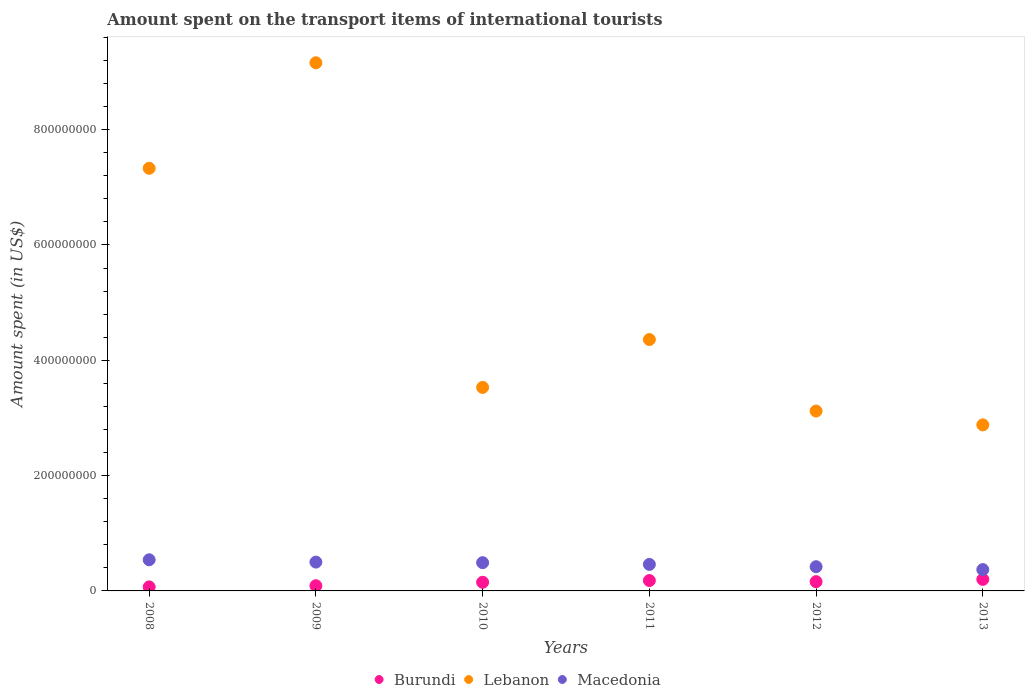How many different coloured dotlines are there?
Ensure brevity in your answer.  3. What is the amount spent on the transport items of international tourists in Macedonia in 2011?
Your response must be concise. 4.60e+07. Across all years, what is the maximum amount spent on the transport items of international tourists in Lebanon?
Offer a very short reply. 9.16e+08. Across all years, what is the minimum amount spent on the transport items of international tourists in Lebanon?
Ensure brevity in your answer.  2.88e+08. What is the total amount spent on the transport items of international tourists in Lebanon in the graph?
Provide a succinct answer. 3.04e+09. What is the difference between the amount spent on the transport items of international tourists in Burundi in 2008 and that in 2011?
Ensure brevity in your answer.  -1.10e+07. What is the difference between the amount spent on the transport items of international tourists in Lebanon in 2008 and the amount spent on the transport items of international tourists in Burundi in 2009?
Provide a short and direct response. 7.24e+08. What is the average amount spent on the transport items of international tourists in Burundi per year?
Your response must be concise. 1.42e+07. In the year 2012, what is the difference between the amount spent on the transport items of international tourists in Lebanon and amount spent on the transport items of international tourists in Macedonia?
Ensure brevity in your answer.  2.70e+08. Is the amount spent on the transport items of international tourists in Macedonia in 2008 less than that in 2012?
Ensure brevity in your answer.  No. Is the difference between the amount spent on the transport items of international tourists in Lebanon in 2008 and 2013 greater than the difference between the amount spent on the transport items of international tourists in Macedonia in 2008 and 2013?
Give a very brief answer. Yes. What is the difference between the highest and the second highest amount spent on the transport items of international tourists in Lebanon?
Ensure brevity in your answer.  1.83e+08. What is the difference between the highest and the lowest amount spent on the transport items of international tourists in Macedonia?
Provide a succinct answer. 1.70e+07. Is the sum of the amount spent on the transport items of international tourists in Macedonia in 2008 and 2009 greater than the maximum amount spent on the transport items of international tourists in Burundi across all years?
Your response must be concise. Yes. Is it the case that in every year, the sum of the amount spent on the transport items of international tourists in Burundi and amount spent on the transport items of international tourists in Macedonia  is greater than the amount spent on the transport items of international tourists in Lebanon?
Your answer should be compact. No. Is the amount spent on the transport items of international tourists in Burundi strictly greater than the amount spent on the transport items of international tourists in Macedonia over the years?
Ensure brevity in your answer.  No. Is the amount spent on the transport items of international tourists in Macedonia strictly less than the amount spent on the transport items of international tourists in Lebanon over the years?
Make the answer very short. Yes. Are the values on the major ticks of Y-axis written in scientific E-notation?
Keep it short and to the point. No. Does the graph contain grids?
Provide a succinct answer. No. Where does the legend appear in the graph?
Keep it short and to the point. Bottom center. How many legend labels are there?
Keep it short and to the point. 3. How are the legend labels stacked?
Make the answer very short. Horizontal. What is the title of the graph?
Make the answer very short. Amount spent on the transport items of international tourists. What is the label or title of the Y-axis?
Make the answer very short. Amount spent (in US$). What is the Amount spent (in US$) in Lebanon in 2008?
Your answer should be very brief. 7.33e+08. What is the Amount spent (in US$) of Macedonia in 2008?
Your response must be concise. 5.40e+07. What is the Amount spent (in US$) of Burundi in 2009?
Offer a very short reply. 9.00e+06. What is the Amount spent (in US$) in Lebanon in 2009?
Make the answer very short. 9.16e+08. What is the Amount spent (in US$) of Burundi in 2010?
Your response must be concise. 1.50e+07. What is the Amount spent (in US$) of Lebanon in 2010?
Keep it short and to the point. 3.53e+08. What is the Amount spent (in US$) of Macedonia in 2010?
Offer a terse response. 4.90e+07. What is the Amount spent (in US$) of Burundi in 2011?
Your answer should be compact. 1.80e+07. What is the Amount spent (in US$) of Lebanon in 2011?
Provide a short and direct response. 4.36e+08. What is the Amount spent (in US$) of Macedonia in 2011?
Your response must be concise. 4.60e+07. What is the Amount spent (in US$) of Burundi in 2012?
Make the answer very short. 1.60e+07. What is the Amount spent (in US$) of Lebanon in 2012?
Provide a short and direct response. 3.12e+08. What is the Amount spent (in US$) of Macedonia in 2012?
Your answer should be very brief. 4.20e+07. What is the Amount spent (in US$) in Lebanon in 2013?
Keep it short and to the point. 2.88e+08. What is the Amount spent (in US$) in Macedonia in 2013?
Ensure brevity in your answer.  3.70e+07. Across all years, what is the maximum Amount spent (in US$) in Lebanon?
Make the answer very short. 9.16e+08. Across all years, what is the maximum Amount spent (in US$) in Macedonia?
Your answer should be very brief. 5.40e+07. Across all years, what is the minimum Amount spent (in US$) of Lebanon?
Offer a terse response. 2.88e+08. Across all years, what is the minimum Amount spent (in US$) of Macedonia?
Your response must be concise. 3.70e+07. What is the total Amount spent (in US$) in Burundi in the graph?
Your response must be concise. 8.50e+07. What is the total Amount spent (in US$) in Lebanon in the graph?
Offer a terse response. 3.04e+09. What is the total Amount spent (in US$) of Macedonia in the graph?
Make the answer very short. 2.78e+08. What is the difference between the Amount spent (in US$) in Burundi in 2008 and that in 2009?
Make the answer very short. -2.00e+06. What is the difference between the Amount spent (in US$) in Lebanon in 2008 and that in 2009?
Provide a short and direct response. -1.83e+08. What is the difference between the Amount spent (in US$) in Macedonia in 2008 and that in 2009?
Offer a very short reply. 4.00e+06. What is the difference between the Amount spent (in US$) of Burundi in 2008 and that in 2010?
Your response must be concise. -8.00e+06. What is the difference between the Amount spent (in US$) of Lebanon in 2008 and that in 2010?
Your answer should be compact. 3.80e+08. What is the difference between the Amount spent (in US$) of Burundi in 2008 and that in 2011?
Your response must be concise. -1.10e+07. What is the difference between the Amount spent (in US$) of Lebanon in 2008 and that in 2011?
Ensure brevity in your answer.  2.97e+08. What is the difference between the Amount spent (in US$) in Macedonia in 2008 and that in 2011?
Offer a very short reply. 8.00e+06. What is the difference between the Amount spent (in US$) in Burundi in 2008 and that in 2012?
Provide a succinct answer. -9.00e+06. What is the difference between the Amount spent (in US$) of Lebanon in 2008 and that in 2012?
Make the answer very short. 4.21e+08. What is the difference between the Amount spent (in US$) in Burundi in 2008 and that in 2013?
Provide a short and direct response. -1.30e+07. What is the difference between the Amount spent (in US$) of Lebanon in 2008 and that in 2013?
Your answer should be compact. 4.45e+08. What is the difference between the Amount spent (in US$) in Macedonia in 2008 and that in 2013?
Provide a short and direct response. 1.70e+07. What is the difference between the Amount spent (in US$) of Burundi in 2009 and that in 2010?
Keep it short and to the point. -6.00e+06. What is the difference between the Amount spent (in US$) of Lebanon in 2009 and that in 2010?
Keep it short and to the point. 5.63e+08. What is the difference between the Amount spent (in US$) of Burundi in 2009 and that in 2011?
Make the answer very short. -9.00e+06. What is the difference between the Amount spent (in US$) in Lebanon in 2009 and that in 2011?
Provide a short and direct response. 4.80e+08. What is the difference between the Amount spent (in US$) of Macedonia in 2009 and that in 2011?
Offer a very short reply. 4.00e+06. What is the difference between the Amount spent (in US$) of Burundi in 2009 and that in 2012?
Ensure brevity in your answer.  -7.00e+06. What is the difference between the Amount spent (in US$) in Lebanon in 2009 and that in 2012?
Offer a very short reply. 6.04e+08. What is the difference between the Amount spent (in US$) in Macedonia in 2009 and that in 2012?
Your response must be concise. 8.00e+06. What is the difference between the Amount spent (in US$) in Burundi in 2009 and that in 2013?
Offer a terse response. -1.10e+07. What is the difference between the Amount spent (in US$) in Lebanon in 2009 and that in 2013?
Offer a very short reply. 6.28e+08. What is the difference between the Amount spent (in US$) of Macedonia in 2009 and that in 2013?
Your response must be concise. 1.30e+07. What is the difference between the Amount spent (in US$) of Burundi in 2010 and that in 2011?
Ensure brevity in your answer.  -3.00e+06. What is the difference between the Amount spent (in US$) of Lebanon in 2010 and that in 2011?
Offer a very short reply. -8.30e+07. What is the difference between the Amount spent (in US$) of Macedonia in 2010 and that in 2011?
Ensure brevity in your answer.  3.00e+06. What is the difference between the Amount spent (in US$) of Burundi in 2010 and that in 2012?
Keep it short and to the point. -1.00e+06. What is the difference between the Amount spent (in US$) in Lebanon in 2010 and that in 2012?
Offer a very short reply. 4.10e+07. What is the difference between the Amount spent (in US$) of Macedonia in 2010 and that in 2012?
Provide a short and direct response. 7.00e+06. What is the difference between the Amount spent (in US$) in Burundi in 2010 and that in 2013?
Provide a short and direct response. -5.00e+06. What is the difference between the Amount spent (in US$) in Lebanon in 2010 and that in 2013?
Offer a terse response. 6.50e+07. What is the difference between the Amount spent (in US$) of Burundi in 2011 and that in 2012?
Offer a terse response. 2.00e+06. What is the difference between the Amount spent (in US$) of Lebanon in 2011 and that in 2012?
Your answer should be compact. 1.24e+08. What is the difference between the Amount spent (in US$) in Lebanon in 2011 and that in 2013?
Give a very brief answer. 1.48e+08. What is the difference between the Amount spent (in US$) of Macedonia in 2011 and that in 2013?
Ensure brevity in your answer.  9.00e+06. What is the difference between the Amount spent (in US$) of Lebanon in 2012 and that in 2013?
Your response must be concise. 2.40e+07. What is the difference between the Amount spent (in US$) of Burundi in 2008 and the Amount spent (in US$) of Lebanon in 2009?
Provide a succinct answer. -9.09e+08. What is the difference between the Amount spent (in US$) of Burundi in 2008 and the Amount spent (in US$) of Macedonia in 2009?
Offer a very short reply. -4.30e+07. What is the difference between the Amount spent (in US$) in Lebanon in 2008 and the Amount spent (in US$) in Macedonia in 2009?
Keep it short and to the point. 6.83e+08. What is the difference between the Amount spent (in US$) of Burundi in 2008 and the Amount spent (in US$) of Lebanon in 2010?
Keep it short and to the point. -3.46e+08. What is the difference between the Amount spent (in US$) of Burundi in 2008 and the Amount spent (in US$) of Macedonia in 2010?
Your response must be concise. -4.20e+07. What is the difference between the Amount spent (in US$) in Lebanon in 2008 and the Amount spent (in US$) in Macedonia in 2010?
Give a very brief answer. 6.84e+08. What is the difference between the Amount spent (in US$) of Burundi in 2008 and the Amount spent (in US$) of Lebanon in 2011?
Provide a short and direct response. -4.29e+08. What is the difference between the Amount spent (in US$) in Burundi in 2008 and the Amount spent (in US$) in Macedonia in 2011?
Keep it short and to the point. -3.90e+07. What is the difference between the Amount spent (in US$) in Lebanon in 2008 and the Amount spent (in US$) in Macedonia in 2011?
Make the answer very short. 6.87e+08. What is the difference between the Amount spent (in US$) in Burundi in 2008 and the Amount spent (in US$) in Lebanon in 2012?
Keep it short and to the point. -3.05e+08. What is the difference between the Amount spent (in US$) of Burundi in 2008 and the Amount spent (in US$) of Macedonia in 2012?
Make the answer very short. -3.50e+07. What is the difference between the Amount spent (in US$) in Lebanon in 2008 and the Amount spent (in US$) in Macedonia in 2012?
Your answer should be very brief. 6.91e+08. What is the difference between the Amount spent (in US$) of Burundi in 2008 and the Amount spent (in US$) of Lebanon in 2013?
Keep it short and to the point. -2.81e+08. What is the difference between the Amount spent (in US$) of Burundi in 2008 and the Amount spent (in US$) of Macedonia in 2013?
Your answer should be very brief. -3.00e+07. What is the difference between the Amount spent (in US$) in Lebanon in 2008 and the Amount spent (in US$) in Macedonia in 2013?
Your answer should be very brief. 6.96e+08. What is the difference between the Amount spent (in US$) in Burundi in 2009 and the Amount spent (in US$) in Lebanon in 2010?
Give a very brief answer. -3.44e+08. What is the difference between the Amount spent (in US$) of Burundi in 2009 and the Amount spent (in US$) of Macedonia in 2010?
Give a very brief answer. -4.00e+07. What is the difference between the Amount spent (in US$) of Lebanon in 2009 and the Amount spent (in US$) of Macedonia in 2010?
Your response must be concise. 8.67e+08. What is the difference between the Amount spent (in US$) of Burundi in 2009 and the Amount spent (in US$) of Lebanon in 2011?
Keep it short and to the point. -4.27e+08. What is the difference between the Amount spent (in US$) of Burundi in 2009 and the Amount spent (in US$) of Macedonia in 2011?
Ensure brevity in your answer.  -3.70e+07. What is the difference between the Amount spent (in US$) of Lebanon in 2009 and the Amount spent (in US$) of Macedonia in 2011?
Provide a succinct answer. 8.70e+08. What is the difference between the Amount spent (in US$) in Burundi in 2009 and the Amount spent (in US$) in Lebanon in 2012?
Provide a short and direct response. -3.03e+08. What is the difference between the Amount spent (in US$) of Burundi in 2009 and the Amount spent (in US$) of Macedonia in 2012?
Your answer should be very brief. -3.30e+07. What is the difference between the Amount spent (in US$) of Lebanon in 2009 and the Amount spent (in US$) of Macedonia in 2012?
Provide a short and direct response. 8.74e+08. What is the difference between the Amount spent (in US$) in Burundi in 2009 and the Amount spent (in US$) in Lebanon in 2013?
Make the answer very short. -2.79e+08. What is the difference between the Amount spent (in US$) of Burundi in 2009 and the Amount spent (in US$) of Macedonia in 2013?
Your response must be concise. -2.80e+07. What is the difference between the Amount spent (in US$) of Lebanon in 2009 and the Amount spent (in US$) of Macedonia in 2013?
Give a very brief answer. 8.79e+08. What is the difference between the Amount spent (in US$) in Burundi in 2010 and the Amount spent (in US$) in Lebanon in 2011?
Your answer should be very brief. -4.21e+08. What is the difference between the Amount spent (in US$) in Burundi in 2010 and the Amount spent (in US$) in Macedonia in 2011?
Make the answer very short. -3.10e+07. What is the difference between the Amount spent (in US$) of Lebanon in 2010 and the Amount spent (in US$) of Macedonia in 2011?
Provide a succinct answer. 3.07e+08. What is the difference between the Amount spent (in US$) of Burundi in 2010 and the Amount spent (in US$) of Lebanon in 2012?
Your answer should be very brief. -2.97e+08. What is the difference between the Amount spent (in US$) in Burundi in 2010 and the Amount spent (in US$) in Macedonia in 2012?
Keep it short and to the point. -2.70e+07. What is the difference between the Amount spent (in US$) of Lebanon in 2010 and the Amount spent (in US$) of Macedonia in 2012?
Offer a terse response. 3.11e+08. What is the difference between the Amount spent (in US$) of Burundi in 2010 and the Amount spent (in US$) of Lebanon in 2013?
Make the answer very short. -2.73e+08. What is the difference between the Amount spent (in US$) of Burundi in 2010 and the Amount spent (in US$) of Macedonia in 2013?
Offer a very short reply. -2.20e+07. What is the difference between the Amount spent (in US$) of Lebanon in 2010 and the Amount spent (in US$) of Macedonia in 2013?
Give a very brief answer. 3.16e+08. What is the difference between the Amount spent (in US$) in Burundi in 2011 and the Amount spent (in US$) in Lebanon in 2012?
Give a very brief answer. -2.94e+08. What is the difference between the Amount spent (in US$) in Burundi in 2011 and the Amount spent (in US$) in Macedonia in 2012?
Keep it short and to the point. -2.40e+07. What is the difference between the Amount spent (in US$) in Lebanon in 2011 and the Amount spent (in US$) in Macedonia in 2012?
Offer a terse response. 3.94e+08. What is the difference between the Amount spent (in US$) of Burundi in 2011 and the Amount spent (in US$) of Lebanon in 2013?
Provide a short and direct response. -2.70e+08. What is the difference between the Amount spent (in US$) in Burundi in 2011 and the Amount spent (in US$) in Macedonia in 2013?
Ensure brevity in your answer.  -1.90e+07. What is the difference between the Amount spent (in US$) of Lebanon in 2011 and the Amount spent (in US$) of Macedonia in 2013?
Your answer should be compact. 3.99e+08. What is the difference between the Amount spent (in US$) in Burundi in 2012 and the Amount spent (in US$) in Lebanon in 2013?
Offer a very short reply. -2.72e+08. What is the difference between the Amount spent (in US$) in Burundi in 2012 and the Amount spent (in US$) in Macedonia in 2013?
Provide a succinct answer. -2.10e+07. What is the difference between the Amount spent (in US$) of Lebanon in 2012 and the Amount spent (in US$) of Macedonia in 2013?
Give a very brief answer. 2.75e+08. What is the average Amount spent (in US$) of Burundi per year?
Offer a very short reply. 1.42e+07. What is the average Amount spent (in US$) of Lebanon per year?
Give a very brief answer. 5.06e+08. What is the average Amount spent (in US$) in Macedonia per year?
Provide a short and direct response. 4.63e+07. In the year 2008, what is the difference between the Amount spent (in US$) in Burundi and Amount spent (in US$) in Lebanon?
Offer a terse response. -7.26e+08. In the year 2008, what is the difference between the Amount spent (in US$) of Burundi and Amount spent (in US$) of Macedonia?
Keep it short and to the point. -4.70e+07. In the year 2008, what is the difference between the Amount spent (in US$) of Lebanon and Amount spent (in US$) of Macedonia?
Your answer should be very brief. 6.79e+08. In the year 2009, what is the difference between the Amount spent (in US$) in Burundi and Amount spent (in US$) in Lebanon?
Provide a succinct answer. -9.07e+08. In the year 2009, what is the difference between the Amount spent (in US$) of Burundi and Amount spent (in US$) of Macedonia?
Provide a succinct answer. -4.10e+07. In the year 2009, what is the difference between the Amount spent (in US$) in Lebanon and Amount spent (in US$) in Macedonia?
Offer a terse response. 8.66e+08. In the year 2010, what is the difference between the Amount spent (in US$) in Burundi and Amount spent (in US$) in Lebanon?
Offer a terse response. -3.38e+08. In the year 2010, what is the difference between the Amount spent (in US$) in Burundi and Amount spent (in US$) in Macedonia?
Ensure brevity in your answer.  -3.40e+07. In the year 2010, what is the difference between the Amount spent (in US$) of Lebanon and Amount spent (in US$) of Macedonia?
Your answer should be compact. 3.04e+08. In the year 2011, what is the difference between the Amount spent (in US$) of Burundi and Amount spent (in US$) of Lebanon?
Provide a succinct answer. -4.18e+08. In the year 2011, what is the difference between the Amount spent (in US$) in Burundi and Amount spent (in US$) in Macedonia?
Offer a terse response. -2.80e+07. In the year 2011, what is the difference between the Amount spent (in US$) in Lebanon and Amount spent (in US$) in Macedonia?
Make the answer very short. 3.90e+08. In the year 2012, what is the difference between the Amount spent (in US$) in Burundi and Amount spent (in US$) in Lebanon?
Offer a very short reply. -2.96e+08. In the year 2012, what is the difference between the Amount spent (in US$) in Burundi and Amount spent (in US$) in Macedonia?
Your response must be concise. -2.60e+07. In the year 2012, what is the difference between the Amount spent (in US$) of Lebanon and Amount spent (in US$) of Macedonia?
Make the answer very short. 2.70e+08. In the year 2013, what is the difference between the Amount spent (in US$) in Burundi and Amount spent (in US$) in Lebanon?
Provide a succinct answer. -2.68e+08. In the year 2013, what is the difference between the Amount spent (in US$) of Burundi and Amount spent (in US$) of Macedonia?
Keep it short and to the point. -1.70e+07. In the year 2013, what is the difference between the Amount spent (in US$) of Lebanon and Amount spent (in US$) of Macedonia?
Your answer should be compact. 2.51e+08. What is the ratio of the Amount spent (in US$) of Lebanon in 2008 to that in 2009?
Your answer should be very brief. 0.8. What is the ratio of the Amount spent (in US$) in Macedonia in 2008 to that in 2009?
Your answer should be compact. 1.08. What is the ratio of the Amount spent (in US$) of Burundi in 2008 to that in 2010?
Your answer should be very brief. 0.47. What is the ratio of the Amount spent (in US$) in Lebanon in 2008 to that in 2010?
Ensure brevity in your answer.  2.08. What is the ratio of the Amount spent (in US$) in Macedonia in 2008 to that in 2010?
Your response must be concise. 1.1. What is the ratio of the Amount spent (in US$) in Burundi in 2008 to that in 2011?
Your response must be concise. 0.39. What is the ratio of the Amount spent (in US$) in Lebanon in 2008 to that in 2011?
Offer a terse response. 1.68. What is the ratio of the Amount spent (in US$) in Macedonia in 2008 to that in 2011?
Give a very brief answer. 1.17. What is the ratio of the Amount spent (in US$) of Burundi in 2008 to that in 2012?
Make the answer very short. 0.44. What is the ratio of the Amount spent (in US$) of Lebanon in 2008 to that in 2012?
Give a very brief answer. 2.35. What is the ratio of the Amount spent (in US$) of Macedonia in 2008 to that in 2012?
Provide a succinct answer. 1.29. What is the ratio of the Amount spent (in US$) in Lebanon in 2008 to that in 2013?
Keep it short and to the point. 2.55. What is the ratio of the Amount spent (in US$) of Macedonia in 2008 to that in 2013?
Your response must be concise. 1.46. What is the ratio of the Amount spent (in US$) in Burundi in 2009 to that in 2010?
Your response must be concise. 0.6. What is the ratio of the Amount spent (in US$) in Lebanon in 2009 to that in 2010?
Give a very brief answer. 2.59. What is the ratio of the Amount spent (in US$) of Macedonia in 2009 to that in 2010?
Offer a terse response. 1.02. What is the ratio of the Amount spent (in US$) of Lebanon in 2009 to that in 2011?
Provide a succinct answer. 2.1. What is the ratio of the Amount spent (in US$) of Macedonia in 2009 to that in 2011?
Provide a short and direct response. 1.09. What is the ratio of the Amount spent (in US$) in Burundi in 2009 to that in 2012?
Offer a very short reply. 0.56. What is the ratio of the Amount spent (in US$) in Lebanon in 2009 to that in 2012?
Your response must be concise. 2.94. What is the ratio of the Amount spent (in US$) in Macedonia in 2009 to that in 2012?
Make the answer very short. 1.19. What is the ratio of the Amount spent (in US$) of Burundi in 2009 to that in 2013?
Offer a very short reply. 0.45. What is the ratio of the Amount spent (in US$) in Lebanon in 2009 to that in 2013?
Ensure brevity in your answer.  3.18. What is the ratio of the Amount spent (in US$) in Macedonia in 2009 to that in 2013?
Ensure brevity in your answer.  1.35. What is the ratio of the Amount spent (in US$) in Burundi in 2010 to that in 2011?
Offer a terse response. 0.83. What is the ratio of the Amount spent (in US$) of Lebanon in 2010 to that in 2011?
Ensure brevity in your answer.  0.81. What is the ratio of the Amount spent (in US$) of Macedonia in 2010 to that in 2011?
Provide a succinct answer. 1.07. What is the ratio of the Amount spent (in US$) in Lebanon in 2010 to that in 2012?
Offer a terse response. 1.13. What is the ratio of the Amount spent (in US$) in Macedonia in 2010 to that in 2012?
Your answer should be compact. 1.17. What is the ratio of the Amount spent (in US$) in Lebanon in 2010 to that in 2013?
Your response must be concise. 1.23. What is the ratio of the Amount spent (in US$) in Macedonia in 2010 to that in 2013?
Provide a short and direct response. 1.32. What is the ratio of the Amount spent (in US$) in Lebanon in 2011 to that in 2012?
Give a very brief answer. 1.4. What is the ratio of the Amount spent (in US$) of Macedonia in 2011 to that in 2012?
Offer a very short reply. 1.1. What is the ratio of the Amount spent (in US$) in Burundi in 2011 to that in 2013?
Make the answer very short. 0.9. What is the ratio of the Amount spent (in US$) of Lebanon in 2011 to that in 2013?
Ensure brevity in your answer.  1.51. What is the ratio of the Amount spent (in US$) in Macedonia in 2011 to that in 2013?
Make the answer very short. 1.24. What is the ratio of the Amount spent (in US$) of Burundi in 2012 to that in 2013?
Give a very brief answer. 0.8. What is the ratio of the Amount spent (in US$) of Macedonia in 2012 to that in 2013?
Your answer should be compact. 1.14. What is the difference between the highest and the second highest Amount spent (in US$) of Lebanon?
Give a very brief answer. 1.83e+08. What is the difference between the highest and the lowest Amount spent (in US$) of Burundi?
Your response must be concise. 1.30e+07. What is the difference between the highest and the lowest Amount spent (in US$) of Lebanon?
Provide a short and direct response. 6.28e+08. What is the difference between the highest and the lowest Amount spent (in US$) of Macedonia?
Keep it short and to the point. 1.70e+07. 